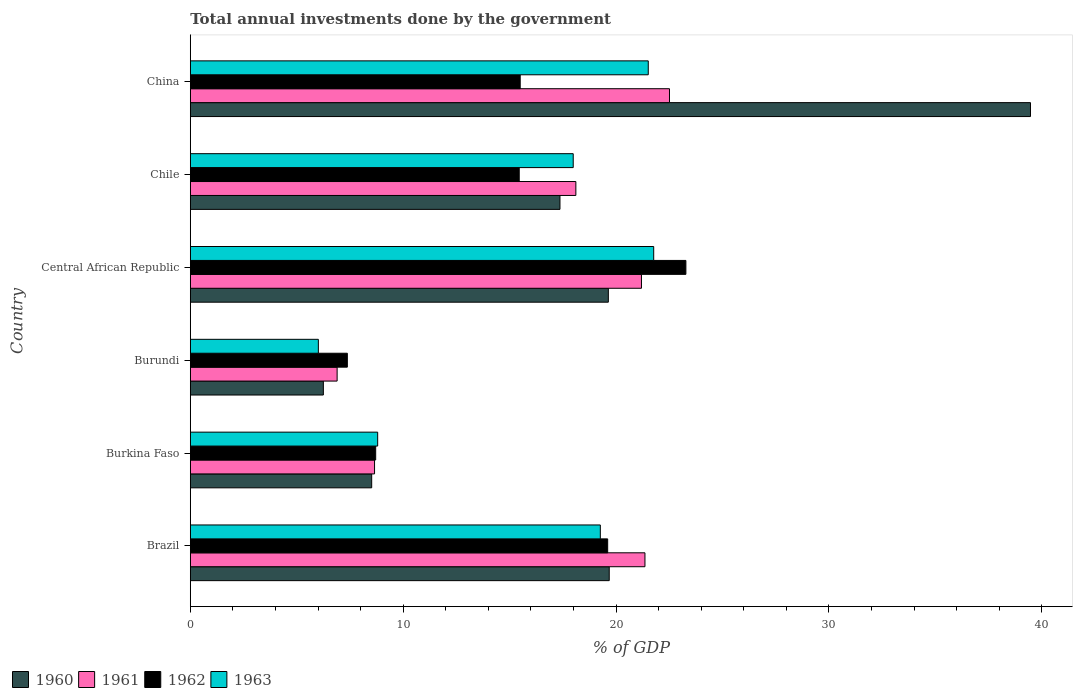How many different coloured bars are there?
Ensure brevity in your answer.  4. How many groups of bars are there?
Keep it short and to the point. 6. Are the number of bars per tick equal to the number of legend labels?
Offer a very short reply. Yes. Are the number of bars on each tick of the Y-axis equal?
Your answer should be very brief. Yes. What is the label of the 5th group of bars from the top?
Make the answer very short. Burkina Faso. What is the total annual investments done by the government in 1963 in China?
Keep it short and to the point. 21.51. Across all countries, what is the maximum total annual investments done by the government in 1961?
Your response must be concise. 22.51. Across all countries, what is the minimum total annual investments done by the government in 1962?
Provide a short and direct response. 7.38. In which country was the total annual investments done by the government in 1963 maximum?
Make the answer very short. Central African Republic. In which country was the total annual investments done by the government in 1960 minimum?
Give a very brief answer. Burundi. What is the total total annual investments done by the government in 1961 in the graph?
Offer a terse response. 98.72. What is the difference between the total annual investments done by the government in 1962 in Chile and that in China?
Your answer should be very brief. -0.05. What is the difference between the total annual investments done by the government in 1963 in Burkina Faso and the total annual investments done by the government in 1962 in China?
Offer a terse response. -6.7. What is the average total annual investments done by the government in 1963 per country?
Keep it short and to the point. 15.89. What is the difference between the total annual investments done by the government in 1961 and total annual investments done by the government in 1960 in Burkina Faso?
Offer a very short reply. 0.13. What is the ratio of the total annual investments done by the government in 1963 in Burkina Faso to that in China?
Your response must be concise. 0.41. What is the difference between the highest and the second highest total annual investments done by the government in 1962?
Ensure brevity in your answer.  3.67. What is the difference between the highest and the lowest total annual investments done by the government in 1961?
Give a very brief answer. 15.61. How many bars are there?
Give a very brief answer. 24. Are all the bars in the graph horizontal?
Make the answer very short. Yes. How many countries are there in the graph?
Keep it short and to the point. 6. What is the difference between two consecutive major ticks on the X-axis?
Give a very brief answer. 10. How many legend labels are there?
Give a very brief answer. 4. How are the legend labels stacked?
Your response must be concise. Horizontal. What is the title of the graph?
Keep it short and to the point. Total annual investments done by the government. What is the label or title of the X-axis?
Provide a succinct answer. % of GDP. What is the label or title of the Y-axis?
Your response must be concise. Country. What is the % of GDP in 1960 in Brazil?
Your answer should be compact. 19.68. What is the % of GDP of 1961 in Brazil?
Your answer should be very brief. 21.36. What is the % of GDP of 1962 in Brazil?
Give a very brief answer. 19.6. What is the % of GDP of 1963 in Brazil?
Give a very brief answer. 19.26. What is the % of GDP in 1960 in Burkina Faso?
Offer a very short reply. 8.52. What is the % of GDP of 1961 in Burkina Faso?
Provide a succinct answer. 8.65. What is the % of GDP in 1962 in Burkina Faso?
Give a very brief answer. 8.71. What is the % of GDP in 1963 in Burkina Faso?
Provide a succinct answer. 8.8. What is the % of GDP in 1960 in Burundi?
Offer a terse response. 6.25. What is the % of GDP of 1961 in Burundi?
Your answer should be compact. 6.9. What is the % of GDP in 1962 in Burundi?
Give a very brief answer. 7.38. What is the % of GDP in 1963 in Burundi?
Your answer should be very brief. 6.02. What is the % of GDP in 1960 in Central African Republic?
Offer a terse response. 19.64. What is the % of GDP in 1961 in Central African Republic?
Keep it short and to the point. 21.19. What is the % of GDP of 1962 in Central African Republic?
Offer a terse response. 23.28. What is the % of GDP of 1963 in Central African Republic?
Ensure brevity in your answer.  21.77. What is the % of GDP in 1960 in Chile?
Ensure brevity in your answer.  17.36. What is the % of GDP of 1961 in Chile?
Keep it short and to the point. 18.11. What is the % of GDP of 1962 in Chile?
Provide a succinct answer. 15.45. What is the % of GDP of 1963 in Chile?
Your response must be concise. 17.99. What is the % of GDP of 1960 in China?
Offer a terse response. 39.46. What is the % of GDP in 1961 in China?
Your answer should be compact. 22.51. What is the % of GDP in 1962 in China?
Offer a terse response. 15.5. What is the % of GDP of 1963 in China?
Ensure brevity in your answer.  21.51. Across all countries, what is the maximum % of GDP in 1960?
Provide a succinct answer. 39.46. Across all countries, what is the maximum % of GDP in 1961?
Offer a terse response. 22.51. Across all countries, what is the maximum % of GDP of 1962?
Provide a succinct answer. 23.28. Across all countries, what is the maximum % of GDP in 1963?
Your answer should be very brief. 21.77. Across all countries, what is the minimum % of GDP of 1960?
Ensure brevity in your answer.  6.25. Across all countries, what is the minimum % of GDP of 1961?
Your answer should be very brief. 6.9. Across all countries, what is the minimum % of GDP in 1962?
Your answer should be very brief. 7.38. Across all countries, what is the minimum % of GDP of 1963?
Keep it short and to the point. 6.02. What is the total % of GDP in 1960 in the graph?
Ensure brevity in your answer.  110.91. What is the total % of GDP of 1961 in the graph?
Your response must be concise. 98.72. What is the total % of GDP in 1962 in the graph?
Your answer should be very brief. 89.92. What is the total % of GDP in 1963 in the graph?
Your answer should be very brief. 95.34. What is the difference between the % of GDP in 1960 in Brazil and that in Burkina Faso?
Your answer should be very brief. 11.16. What is the difference between the % of GDP of 1961 in Brazil and that in Burkina Faso?
Your answer should be compact. 12.7. What is the difference between the % of GDP in 1962 in Brazil and that in Burkina Faso?
Keep it short and to the point. 10.9. What is the difference between the % of GDP in 1963 in Brazil and that in Burkina Faso?
Your response must be concise. 10.46. What is the difference between the % of GDP in 1960 in Brazil and that in Burundi?
Provide a short and direct response. 13.43. What is the difference between the % of GDP of 1961 in Brazil and that in Burundi?
Give a very brief answer. 14.46. What is the difference between the % of GDP of 1962 in Brazil and that in Burundi?
Your response must be concise. 12.23. What is the difference between the % of GDP of 1963 in Brazil and that in Burundi?
Give a very brief answer. 13.24. What is the difference between the % of GDP in 1960 in Brazil and that in Central African Republic?
Offer a very short reply. 0.04. What is the difference between the % of GDP in 1961 in Brazil and that in Central African Republic?
Offer a terse response. 0.16. What is the difference between the % of GDP of 1962 in Brazil and that in Central African Republic?
Make the answer very short. -3.67. What is the difference between the % of GDP in 1963 in Brazil and that in Central African Republic?
Your answer should be very brief. -2.51. What is the difference between the % of GDP of 1960 in Brazil and that in Chile?
Your response must be concise. 2.31. What is the difference between the % of GDP of 1961 in Brazil and that in Chile?
Provide a short and direct response. 3.25. What is the difference between the % of GDP of 1962 in Brazil and that in Chile?
Your response must be concise. 4.15. What is the difference between the % of GDP in 1963 in Brazil and that in Chile?
Give a very brief answer. 1.27. What is the difference between the % of GDP in 1960 in Brazil and that in China?
Ensure brevity in your answer.  -19.79. What is the difference between the % of GDP of 1961 in Brazil and that in China?
Your answer should be very brief. -1.15. What is the difference between the % of GDP of 1962 in Brazil and that in China?
Your answer should be very brief. 4.11. What is the difference between the % of GDP of 1963 in Brazil and that in China?
Offer a terse response. -2.25. What is the difference between the % of GDP in 1960 in Burkina Faso and that in Burundi?
Offer a terse response. 2.27. What is the difference between the % of GDP in 1961 in Burkina Faso and that in Burundi?
Offer a terse response. 1.76. What is the difference between the % of GDP in 1962 in Burkina Faso and that in Burundi?
Keep it short and to the point. 1.33. What is the difference between the % of GDP of 1963 in Burkina Faso and that in Burundi?
Provide a short and direct response. 2.79. What is the difference between the % of GDP of 1960 in Burkina Faso and that in Central African Republic?
Provide a succinct answer. -11.12. What is the difference between the % of GDP in 1961 in Burkina Faso and that in Central African Republic?
Your response must be concise. -12.54. What is the difference between the % of GDP in 1962 in Burkina Faso and that in Central African Republic?
Give a very brief answer. -14.57. What is the difference between the % of GDP of 1963 in Burkina Faso and that in Central African Republic?
Your answer should be very brief. -12.97. What is the difference between the % of GDP in 1960 in Burkina Faso and that in Chile?
Offer a terse response. -8.84. What is the difference between the % of GDP in 1961 in Burkina Faso and that in Chile?
Give a very brief answer. -9.46. What is the difference between the % of GDP in 1962 in Burkina Faso and that in Chile?
Provide a short and direct response. -6.74. What is the difference between the % of GDP of 1963 in Burkina Faso and that in Chile?
Offer a very short reply. -9.19. What is the difference between the % of GDP of 1960 in Burkina Faso and that in China?
Ensure brevity in your answer.  -30.94. What is the difference between the % of GDP of 1961 in Burkina Faso and that in China?
Your answer should be compact. -13.85. What is the difference between the % of GDP in 1962 in Burkina Faso and that in China?
Ensure brevity in your answer.  -6.79. What is the difference between the % of GDP of 1963 in Burkina Faso and that in China?
Your answer should be compact. -12.71. What is the difference between the % of GDP in 1960 in Burundi and that in Central African Republic?
Provide a short and direct response. -13.39. What is the difference between the % of GDP in 1961 in Burundi and that in Central African Republic?
Provide a succinct answer. -14.3. What is the difference between the % of GDP of 1962 in Burundi and that in Central African Republic?
Offer a terse response. -15.9. What is the difference between the % of GDP of 1963 in Burundi and that in Central African Republic?
Your answer should be compact. -15.75. What is the difference between the % of GDP of 1960 in Burundi and that in Chile?
Provide a succinct answer. -11.11. What is the difference between the % of GDP of 1961 in Burundi and that in Chile?
Offer a terse response. -11.21. What is the difference between the % of GDP in 1962 in Burundi and that in Chile?
Offer a terse response. -8.07. What is the difference between the % of GDP of 1963 in Burundi and that in Chile?
Provide a short and direct response. -11.97. What is the difference between the % of GDP in 1960 in Burundi and that in China?
Your answer should be compact. -33.21. What is the difference between the % of GDP of 1961 in Burundi and that in China?
Your answer should be very brief. -15.61. What is the difference between the % of GDP of 1962 in Burundi and that in China?
Provide a short and direct response. -8.12. What is the difference between the % of GDP of 1963 in Burundi and that in China?
Provide a succinct answer. -15.5. What is the difference between the % of GDP in 1960 in Central African Republic and that in Chile?
Offer a terse response. 2.27. What is the difference between the % of GDP of 1961 in Central African Republic and that in Chile?
Ensure brevity in your answer.  3.08. What is the difference between the % of GDP of 1962 in Central African Republic and that in Chile?
Your answer should be very brief. 7.83. What is the difference between the % of GDP of 1963 in Central African Republic and that in Chile?
Your answer should be very brief. 3.78. What is the difference between the % of GDP in 1960 in Central African Republic and that in China?
Offer a terse response. -19.83. What is the difference between the % of GDP in 1961 in Central African Republic and that in China?
Provide a short and direct response. -1.32. What is the difference between the % of GDP of 1962 in Central African Republic and that in China?
Make the answer very short. 7.78. What is the difference between the % of GDP of 1963 in Central African Republic and that in China?
Offer a terse response. 0.26. What is the difference between the % of GDP of 1960 in Chile and that in China?
Give a very brief answer. -22.1. What is the difference between the % of GDP of 1961 in Chile and that in China?
Your answer should be compact. -4.4. What is the difference between the % of GDP in 1962 in Chile and that in China?
Your response must be concise. -0.05. What is the difference between the % of GDP in 1963 in Chile and that in China?
Ensure brevity in your answer.  -3.52. What is the difference between the % of GDP of 1960 in Brazil and the % of GDP of 1961 in Burkina Faso?
Your answer should be compact. 11.02. What is the difference between the % of GDP of 1960 in Brazil and the % of GDP of 1962 in Burkina Faso?
Provide a succinct answer. 10.97. What is the difference between the % of GDP in 1960 in Brazil and the % of GDP in 1963 in Burkina Faso?
Offer a terse response. 10.88. What is the difference between the % of GDP of 1961 in Brazil and the % of GDP of 1962 in Burkina Faso?
Your response must be concise. 12.65. What is the difference between the % of GDP in 1961 in Brazil and the % of GDP in 1963 in Burkina Faso?
Ensure brevity in your answer.  12.55. What is the difference between the % of GDP of 1962 in Brazil and the % of GDP of 1963 in Burkina Faso?
Keep it short and to the point. 10.8. What is the difference between the % of GDP of 1960 in Brazil and the % of GDP of 1961 in Burundi?
Ensure brevity in your answer.  12.78. What is the difference between the % of GDP of 1960 in Brazil and the % of GDP of 1962 in Burundi?
Provide a succinct answer. 12.3. What is the difference between the % of GDP of 1960 in Brazil and the % of GDP of 1963 in Burundi?
Give a very brief answer. 13.66. What is the difference between the % of GDP in 1961 in Brazil and the % of GDP in 1962 in Burundi?
Provide a short and direct response. 13.98. What is the difference between the % of GDP in 1961 in Brazil and the % of GDP in 1963 in Burundi?
Keep it short and to the point. 15.34. What is the difference between the % of GDP in 1962 in Brazil and the % of GDP in 1963 in Burundi?
Your answer should be compact. 13.59. What is the difference between the % of GDP of 1960 in Brazil and the % of GDP of 1961 in Central African Republic?
Offer a very short reply. -1.51. What is the difference between the % of GDP in 1960 in Brazil and the % of GDP in 1962 in Central African Republic?
Your answer should be compact. -3.6. What is the difference between the % of GDP of 1960 in Brazil and the % of GDP of 1963 in Central African Republic?
Your answer should be compact. -2.09. What is the difference between the % of GDP of 1961 in Brazil and the % of GDP of 1962 in Central African Republic?
Provide a succinct answer. -1.92. What is the difference between the % of GDP of 1961 in Brazil and the % of GDP of 1963 in Central African Republic?
Keep it short and to the point. -0.41. What is the difference between the % of GDP in 1962 in Brazil and the % of GDP in 1963 in Central African Republic?
Offer a very short reply. -2.16. What is the difference between the % of GDP of 1960 in Brazil and the % of GDP of 1961 in Chile?
Your response must be concise. 1.57. What is the difference between the % of GDP of 1960 in Brazil and the % of GDP of 1962 in Chile?
Offer a very short reply. 4.23. What is the difference between the % of GDP of 1960 in Brazil and the % of GDP of 1963 in Chile?
Your answer should be very brief. 1.69. What is the difference between the % of GDP of 1961 in Brazil and the % of GDP of 1962 in Chile?
Keep it short and to the point. 5.91. What is the difference between the % of GDP in 1961 in Brazil and the % of GDP in 1963 in Chile?
Offer a terse response. 3.37. What is the difference between the % of GDP in 1962 in Brazil and the % of GDP in 1963 in Chile?
Your response must be concise. 1.62. What is the difference between the % of GDP in 1960 in Brazil and the % of GDP in 1961 in China?
Your answer should be compact. -2.83. What is the difference between the % of GDP of 1960 in Brazil and the % of GDP of 1962 in China?
Provide a short and direct response. 4.18. What is the difference between the % of GDP of 1960 in Brazil and the % of GDP of 1963 in China?
Ensure brevity in your answer.  -1.83. What is the difference between the % of GDP in 1961 in Brazil and the % of GDP in 1962 in China?
Your response must be concise. 5.86. What is the difference between the % of GDP of 1961 in Brazil and the % of GDP of 1963 in China?
Provide a succinct answer. -0.16. What is the difference between the % of GDP of 1962 in Brazil and the % of GDP of 1963 in China?
Offer a terse response. -1.91. What is the difference between the % of GDP in 1960 in Burkina Faso and the % of GDP in 1961 in Burundi?
Keep it short and to the point. 1.62. What is the difference between the % of GDP of 1960 in Burkina Faso and the % of GDP of 1962 in Burundi?
Your answer should be very brief. 1.14. What is the difference between the % of GDP in 1960 in Burkina Faso and the % of GDP in 1963 in Burundi?
Keep it short and to the point. 2.5. What is the difference between the % of GDP in 1961 in Burkina Faso and the % of GDP in 1962 in Burundi?
Give a very brief answer. 1.28. What is the difference between the % of GDP of 1961 in Burkina Faso and the % of GDP of 1963 in Burundi?
Ensure brevity in your answer.  2.64. What is the difference between the % of GDP in 1962 in Burkina Faso and the % of GDP in 1963 in Burundi?
Provide a succinct answer. 2.69. What is the difference between the % of GDP of 1960 in Burkina Faso and the % of GDP of 1961 in Central African Republic?
Your answer should be very brief. -12.67. What is the difference between the % of GDP of 1960 in Burkina Faso and the % of GDP of 1962 in Central African Republic?
Offer a very short reply. -14.76. What is the difference between the % of GDP of 1960 in Burkina Faso and the % of GDP of 1963 in Central African Republic?
Make the answer very short. -13.25. What is the difference between the % of GDP in 1961 in Burkina Faso and the % of GDP in 1962 in Central African Republic?
Your answer should be compact. -14.62. What is the difference between the % of GDP in 1961 in Burkina Faso and the % of GDP in 1963 in Central African Republic?
Ensure brevity in your answer.  -13.11. What is the difference between the % of GDP of 1962 in Burkina Faso and the % of GDP of 1963 in Central African Republic?
Your answer should be very brief. -13.06. What is the difference between the % of GDP of 1960 in Burkina Faso and the % of GDP of 1961 in Chile?
Make the answer very short. -9.59. What is the difference between the % of GDP of 1960 in Burkina Faso and the % of GDP of 1962 in Chile?
Make the answer very short. -6.93. What is the difference between the % of GDP in 1960 in Burkina Faso and the % of GDP in 1963 in Chile?
Your response must be concise. -9.47. What is the difference between the % of GDP of 1961 in Burkina Faso and the % of GDP of 1962 in Chile?
Make the answer very short. -6.8. What is the difference between the % of GDP in 1961 in Burkina Faso and the % of GDP in 1963 in Chile?
Offer a very short reply. -9.33. What is the difference between the % of GDP in 1962 in Burkina Faso and the % of GDP in 1963 in Chile?
Your answer should be very brief. -9.28. What is the difference between the % of GDP in 1960 in Burkina Faso and the % of GDP in 1961 in China?
Offer a terse response. -13.99. What is the difference between the % of GDP of 1960 in Burkina Faso and the % of GDP of 1962 in China?
Keep it short and to the point. -6.98. What is the difference between the % of GDP in 1960 in Burkina Faso and the % of GDP in 1963 in China?
Make the answer very short. -12.99. What is the difference between the % of GDP in 1961 in Burkina Faso and the % of GDP in 1962 in China?
Offer a very short reply. -6.84. What is the difference between the % of GDP of 1961 in Burkina Faso and the % of GDP of 1963 in China?
Keep it short and to the point. -12.86. What is the difference between the % of GDP of 1962 in Burkina Faso and the % of GDP of 1963 in China?
Offer a terse response. -12.8. What is the difference between the % of GDP in 1960 in Burundi and the % of GDP in 1961 in Central African Republic?
Offer a terse response. -14.94. What is the difference between the % of GDP in 1960 in Burundi and the % of GDP in 1962 in Central African Republic?
Your response must be concise. -17.03. What is the difference between the % of GDP of 1960 in Burundi and the % of GDP of 1963 in Central African Republic?
Ensure brevity in your answer.  -15.52. What is the difference between the % of GDP of 1961 in Burundi and the % of GDP of 1962 in Central African Republic?
Keep it short and to the point. -16.38. What is the difference between the % of GDP in 1961 in Burundi and the % of GDP in 1963 in Central African Republic?
Provide a short and direct response. -14.87. What is the difference between the % of GDP in 1962 in Burundi and the % of GDP in 1963 in Central African Republic?
Your answer should be very brief. -14.39. What is the difference between the % of GDP of 1960 in Burundi and the % of GDP of 1961 in Chile?
Give a very brief answer. -11.86. What is the difference between the % of GDP in 1960 in Burundi and the % of GDP in 1962 in Chile?
Provide a short and direct response. -9.2. What is the difference between the % of GDP in 1960 in Burundi and the % of GDP in 1963 in Chile?
Give a very brief answer. -11.74. What is the difference between the % of GDP of 1961 in Burundi and the % of GDP of 1962 in Chile?
Keep it short and to the point. -8.55. What is the difference between the % of GDP in 1961 in Burundi and the % of GDP in 1963 in Chile?
Provide a short and direct response. -11.09. What is the difference between the % of GDP in 1962 in Burundi and the % of GDP in 1963 in Chile?
Give a very brief answer. -10.61. What is the difference between the % of GDP in 1960 in Burundi and the % of GDP in 1961 in China?
Make the answer very short. -16.26. What is the difference between the % of GDP in 1960 in Burundi and the % of GDP in 1962 in China?
Make the answer very short. -9.25. What is the difference between the % of GDP of 1960 in Burundi and the % of GDP of 1963 in China?
Make the answer very short. -15.26. What is the difference between the % of GDP in 1961 in Burundi and the % of GDP in 1962 in China?
Keep it short and to the point. -8.6. What is the difference between the % of GDP in 1961 in Burundi and the % of GDP in 1963 in China?
Make the answer very short. -14.61. What is the difference between the % of GDP in 1962 in Burundi and the % of GDP in 1963 in China?
Your response must be concise. -14.13. What is the difference between the % of GDP in 1960 in Central African Republic and the % of GDP in 1961 in Chile?
Offer a very short reply. 1.53. What is the difference between the % of GDP in 1960 in Central African Republic and the % of GDP in 1962 in Chile?
Provide a short and direct response. 4.19. What is the difference between the % of GDP in 1960 in Central African Republic and the % of GDP in 1963 in Chile?
Give a very brief answer. 1.65. What is the difference between the % of GDP of 1961 in Central African Republic and the % of GDP of 1962 in Chile?
Your answer should be very brief. 5.74. What is the difference between the % of GDP of 1961 in Central African Republic and the % of GDP of 1963 in Chile?
Make the answer very short. 3.21. What is the difference between the % of GDP in 1962 in Central African Republic and the % of GDP in 1963 in Chile?
Your response must be concise. 5.29. What is the difference between the % of GDP of 1960 in Central African Republic and the % of GDP of 1961 in China?
Your answer should be very brief. -2.87. What is the difference between the % of GDP of 1960 in Central African Republic and the % of GDP of 1962 in China?
Provide a succinct answer. 4.14. What is the difference between the % of GDP in 1960 in Central African Republic and the % of GDP in 1963 in China?
Offer a terse response. -1.88. What is the difference between the % of GDP in 1961 in Central African Republic and the % of GDP in 1962 in China?
Your response must be concise. 5.7. What is the difference between the % of GDP in 1961 in Central African Republic and the % of GDP in 1963 in China?
Provide a succinct answer. -0.32. What is the difference between the % of GDP in 1962 in Central African Republic and the % of GDP in 1963 in China?
Provide a short and direct response. 1.77. What is the difference between the % of GDP of 1960 in Chile and the % of GDP of 1961 in China?
Your answer should be very brief. -5.14. What is the difference between the % of GDP of 1960 in Chile and the % of GDP of 1962 in China?
Offer a terse response. 1.87. What is the difference between the % of GDP in 1960 in Chile and the % of GDP in 1963 in China?
Provide a succinct answer. -4.15. What is the difference between the % of GDP of 1961 in Chile and the % of GDP of 1962 in China?
Keep it short and to the point. 2.61. What is the difference between the % of GDP of 1961 in Chile and the % of GDP of 1963 in China?
Your answer should be very brief. -3.4. What is the difference between the % of GDP in 1962 in Chile and the % of GDP in 1963 in China?
Make the answer very short. -6.06. What is the average % of GDP in 1960 per country?
Offer a terse response. 18.49. What is the average % of GDP of 1961 per country?
Your response must be concise. 16.45. What is the average % of GDP in 1962 per country?
Provide a short and direct response. 14.99. What is the average % of GDP of 1963 per country?
Provide a short and direct response. 15.89. What is the difference between the % of GDP in 1960 and % of GDP in 1961 in Brazil?
Offer a very short reply. -1.68. What is the difference between the % of GDP in 1960 and % of GDP in 1962 in Brazil?
Your answer should be very brief. 0.07. What is the difference between the % of GDP in 1960 and % of GDP in 1963 in Brazil?
Provide a short and direct response. 0.42. What is the difference between the % of GDP of 1961 and % of GDP of 1962 in Brazil?
Keep it short and to the point. 1.75. What is the difference between the % of GDP of 1961 and % of GDP of 1963 in Brazil?
Provide a short and direct response. 2.1. What is the difference between the % of GDP of 1962 and % of GDP of 1963 in Brazil?
Offer a very short reply. 0.34. What is the difference between the % of GDP of 1960 and % of GDP of 1961 in Burkina Faso?
Provide a succinct answer. -0.13. What is the difference between the % of GDP of 1960 and % of GDP of 1962 in Burkina Faso?
Your answer should be compact. -0.19. What is the difference between the % of GDP of 1960 and % of GDP of 1963 in Burkina Faso?
Provide a succinct answer. -0.28. What is the difference between the % of GDP of 1961 and % of GDP of 1962 in Burkina Faso?
Your answer should be very brief. -0.05. What is the difference between the % of GDP of 1961 and % of GDP of 1963 in Burkina Faso?
Ensure brevity in your answer.  -0.15. What is the difference between the % of GDP in 1962 and % of GDP in 1963 in Burkina Faso?
Your answer should be very brief. -0.09. What is the difference between the % of GDP in 1960 and % of GDP in 1961 in Burundi?
Offer a terse response. -0.65. What is the difference between the % of GDP in 1960 and % of GDP in 1962 in Burundi?
Keep it short and to the point. -1.13. What is the difference between the % of GDP of 1960 and % of GDP of 1963 in Burundi?
Provide a succinct answer. 0.23. What is the difference between the % of GDP of 1961 and % of GDP of 1962 in Burundi?
Provide a succinct answer. -0.48. What is the difference between the % of GDP of 1961 and % of GDP of 1963 in Burundi?
Provide a succinct answer. 0.88. What is the difference between the % of GDP of 1962 and % of GDP of 1963 in Burundi?
Make the answer very short. 1.36. What is the difference between the % of GDP in 1960 and % of GDP in 1961 in Central African Republic?
Provide a short and direct response. -1.56. What is the difference between the % of GDP of 1960 and % of GDP of 1962 in Central African Republic?
Provide a succinct answer. -3.64. What is the difference between the % of GDP in 1960 and % of GDP in 1963 in Central African Republic?
Your answer should be compact. -2.13. What is the difference between the % of GDP of 1961 and % of GDP of 1962 in Central African Republic?
Offer a very short reply. -2.09. What is the difference between the % of GDP in 1961 and % of GDP in 1963 in Central African Republic?
Ensure brevity in your answer.  -0.57. What is the difference between the % of GDP of 1962 and % of GDP of 1963 in Central African Republic?
Make the answer very short. 1.51. What is the difference between the % of GDP in 1960 and % of GDP in 1961 in Chile?
Offer a terse response. -0.75. What is the difference between the % of GDP of 1960 and % of GDP of 1962 in Chile?
Your response must be concise. 1.91. What is the difference between the % of GDP of 1960 and % of GDP of 1963 in Chile?
Ensure brevity in your answer.  -0.62. What is the difference between the % of GDP of 1961 and % of GDP of 1962 in Chile?
Your response must be concise. 2.66. What is the difference between the % of GDP of 1961 and % of GDP of 1963 in Chile?
Keep it short and to the point. 0.12. What is the difference between the % of GDP of 1962 and % of GDP of 1963 in Chile?
Provide a short and direct response. -2.54. What is the difference between the % of GDP of 1960 and % of GDP of 1961 in China?
Make the answer very short. 16.96. What is the difference between the % of GDP of 1960 and % of GDP of 1962 in China?
Give a very brief answer. 23.97. What is the difference between the % of GDP of 1960 and % of GDP of 1963 in China?
Offer a very short reply. 17.95. What is the difference between the % of GDP in 1961 and % of GDP in 1962 in China?
Keep it short and to the point. 7.01. What is the difference between the % of GDP in 1961 and % of GDP in 1963 in China?
Your response must be concise. 1. What is the difference between the % of GDP of 1962 and % of GDP of 1963 in China?
Offer a terse response. -6.01. What is the ratio of the % of GDP of 1960 in Brazil to that in Burkina Faso?
Offer a terse response. 2.31. What is the ratio of the % of GDP in 1961 in Brazil to that in Burkina Faso?
Keep it short and to the point. 2.47. What is the ratio of the % of GDP of 1962 in Brazil to that in Burkina Faso?
Ensure brevity in your answer.  2.25. What is the ratio of the % of GDP in 1963 in Brazil to that in Burkina Faso?
Give a very brief answer. 2.19. What is the ratio of the % of GDP of 1960 in Brazil to that in Burundi?
Your answer should be compact. 3.15. What is the ratio of the % of GDP of 1961 in Brazil to that in Burundi?
Keep it short and to the point. 3.1. What is the ratio of the % of GDP of 1962 in Brazil to that in Burundi?
Give a very brief answer. 2.66. What is the ratio of the % of GDP of 1963 in Brazil to that in Burundi?
Offer a very short reply. 3.2. What is the ratio of the % of GDP of 1960 in Brazil to that in Central African Republic?
Provide a succinct answer. 1. What is the ratio of the % of GDP of 1961 in Brazil to that in Central African Republic?
Keep it short and to the point. 1.01. What is the ratio of the % of GDP of 1962 in Brazil to that in Central African Republic?
Ensure brevity in your answer.  0.84. What is the ratio of the % of GDP of 1963 in Brazil to that in Central African Republic?
Your response must be concise. 0.88. What is the ratio of the % of GDP in 1960 in Brazil to that in Chile?
Make the answer very short. 1.13. What is the ratio of the % of GDP of 1961 in Brazil to that in Chile?
Keep it short and to the point. 1.18. What is the ratio of the % of GDP of 1962 in Brazil to that in Chile?
Give a very brief answer. 1.27. What is the ratio of the % of GDP of 1963 in Brazil to that in Chile?
Provide a succinct answer. 1.07. What is the ratio of the % of GDP in 1960 in Brazil to that in China?
Your response must be concise. 0.5. What is the ratio of the % of GDP of 1961 in Brazil to that in China?
Keep it short and to the point. 0.95. What is the ratio of the % of GDP of 1962 in Brazil to that in China?
Keep it short and to the point. 1.27. What is the ratio of the % of GDP of 1963 in Brazil to that in China?
Offer a very short reply. 0.9. What is the ratio of the % of GDP in 1960 in Burkina Faso to that in Burundi?
Ensure brevity in your answer.  1.36. What is the ratio of the % of GDP of 1961 in Burkina Faso to that in Burundi?
Your answer should be very brief. 1.25. What is the ratio of the % of GDP in 1962 in Burkina Faso to that in Burundi?
Ensure brevity in your answer.  1.18. What is the ratio of the % of GDP in 1963 in Burkina Faso to that in Burundi?
Provide a succinct answer. 1.46. What is the ratio of the % of GDP of 1960 in Burkina Faso to that in Central African Republic?
Keep it short and to the point. 0.43. What is the ratio of the % of GDP of 1961 in Burkina Faso to that in Central African Republic?
Keep it short and to the point. 0.41. What is the ratio of the % of GDP in 1962 in Burkina Faso to that in Central African Republic?
Provide a short and direct response. 0.37. What is the ratio of the % of GDP of 1963 in Burkina Faso to that in Central African Republic?
Your answer should be very brief. 0.4. What is the ratio of the % of GDP in 1960 in Burkina Faso to that in Chile?
Ensure brevity in your answer.  0.49. What is the ratio of the % of GDP in 1961 in Burkina Faso to that in Chile?
Offer a terse response. 0.48. What is the ratio of the % of GDP of 1962 in Burkina Faso to that in Chile?
Give a very brief answer. 0.56. What is the ratio of the % of GDP of 1963 in Burkina Faso to that in Chile?
Your answer should be very brief. 0.49. What is the ratio of the % of GDP of 1960 in Burkina Faso to that in China?
Keep it short and to the point. 0.22. What is the ratio of the % of GDP of 1961 in Burkina Faso to that in China?
Your answer should be very brief. 0.38. What is the ratio of the % of GDP of 1962 in Burkina Faso to that in China?
Provide a succinct answer. 0.56. What is the ratio of the % of GDP in 1963 in Burkina Faso to that in China?
Your answer should be very brief. 0.41. What is the ratio of the % of GDP of 1960 in Burundi to that in Central African Republic?
Your answer should be compact. 0.32. What is the ratio of the % of GDP of 1961 in Burundi to that in Central African Republic?
Offer a very short reply. 0.33. What is the ratio of the % of GDP of 1962 in Burundi to that in Central African Republic?
Provide a short and direct response. 0.32. What is the ratio of the % of GDP in 1963 in Burundi to that in Central African Republic?
Keep it short and to the point. 0.28. What is the ratio of the % of GDP of 1960 in Burundi to that in Chile?
Give a very brief answer. 0.36. What is the ratio of the % of GDP of 1961 in Burundi to that in Chile?
Keep it short and to the point. 0.38. What is the ratio of the % of GDP in 1962 in Burundi to that in Chile?
Make the answer very short. 0.48. What is the ratio of the % of GDP in 1963 in Burundi to that in Chile?
Make the answer very short. 0.33. What is the ratio of the % of GDP of 1960 in Burundi to that in China?
Keep it short and to the point. 0.16. What is the ratio of the % of GDP in 1961 in Burundi to that in China?
Offer a very short reply. 0.31. What is the ratio of the % of GDP in 1962 in Burundi to that in China?
Make the answer very short. 0.48. What is the ratio of the % of GDP of 1963 in Burundi to that in China?
Your answer should be compact. 0.28. What is the ratio of the % of GDP of 1960 in Central African Republic to that in Chile?
Provide a succinct answer. 1.13. What is the ratio of the % of GDP of 1961 in Central African Republic to that in Chile?
Provide a succinct answer. 1.17. What is the ratio of the % of GDP in 1962 in Central African Republic to that in Chile?
Your answer should be compact. 1.51. What is the ratio of the % of GDP in 1963 in Central African Republic to that in Chile?
Keep it short and to the point. 1.21. What is the ratio of the % of GDP of 1960 in Central African Republic to that in China?
Your answer should be very brief. 0.5. What is the ratio of the % of GDP in 1961 in Central African Republic to that in China?
Ensure brevity in your answer.  0.94. What is the ratio of the % of GDP in 1962 in Central African Republic to that in China?
Offer a terse response. 1.5. What is the ratio of the % of GDP in 1963 in Central African Republic to that in China?
Give a very brief answer. 1.01. What is the ratio of the % of GDP of 1960 in Chile to that in China?
Provide a succinct answer. 0.44. What is the ratio of the % of GDP in 1961 in Chile to that in China?
Your response must be concise. 0.8. What is the ratio of the % of GDP of 1963 in Chile to that in China?
Your answer should be compact. 0.84. What is the difference between the highest and the second highest % of GDP of 1960?
Your answer should be compact. 19.79. What is the difference between the highest and the second highest % of GDP of 1961?
Give a very brief answer. 1.15. What is the difference between the highest and the second highest % of GDP in 1962?
Keep it short and to the point. 3.67. What is the difference between the highest and the second highest % of GDP of 1963?
Your response must be concise. 0.26. What is the difference between the highest and the lowest % of GDP of 1960?
Your answer should be compact. 33.21. What is the difference between the highest and the lowest % of GDP in 1961?
Provide a short and direct response. 15.61. What is the difference between the highest and the lowest % of GDP of 1962?
Ensure brevity in your answer.  15.9. What is the difference between the highest and the lowest % of GDP of 1963?
Make the answer very short. 15.75. 